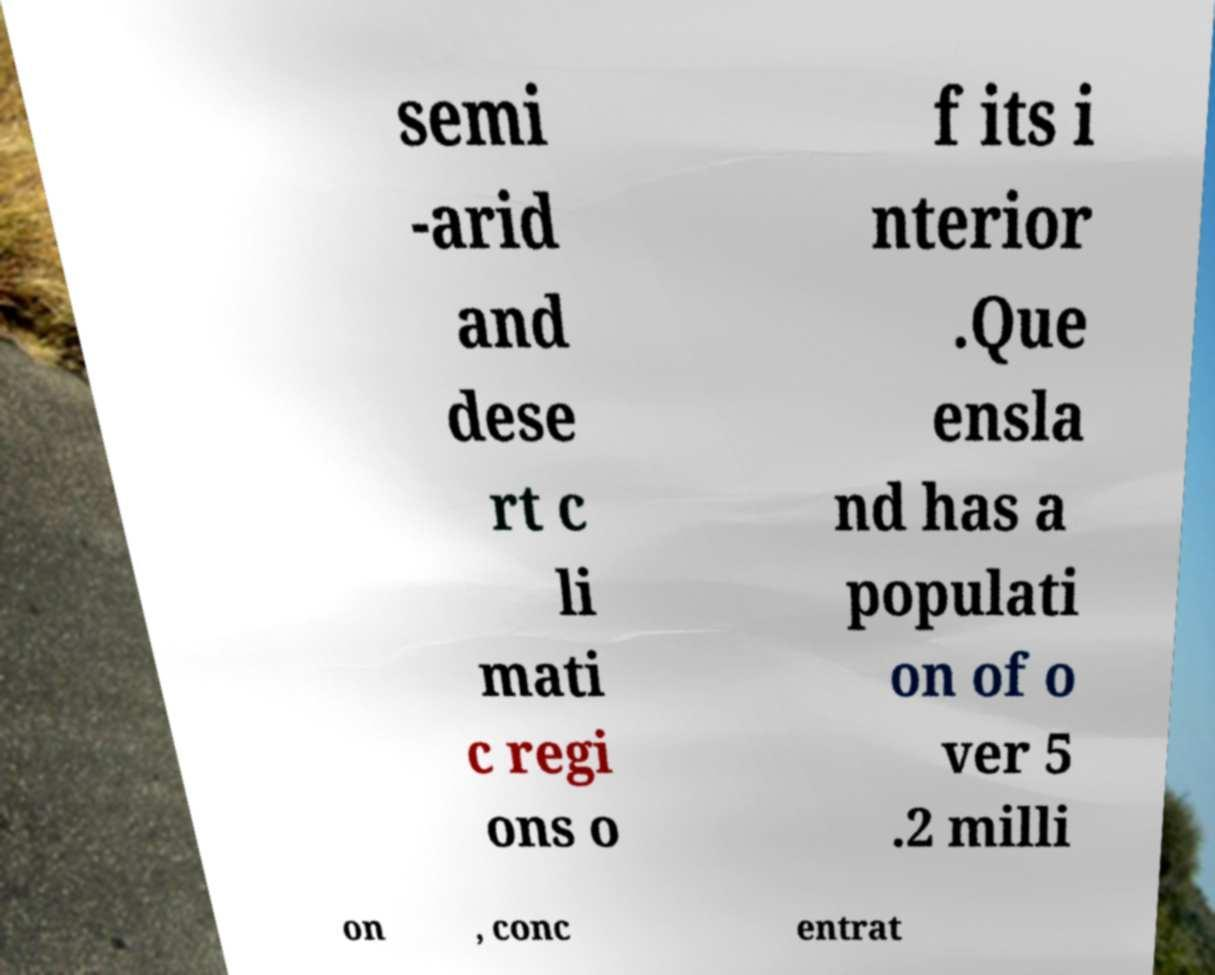Please read and relay the text visible in this image. What does it say? semi -arid and dese rt c li mati c regi ons o f its i nterior .Que ensla nd has a populati on of o ver 5 .2 milli on , conc entrat 